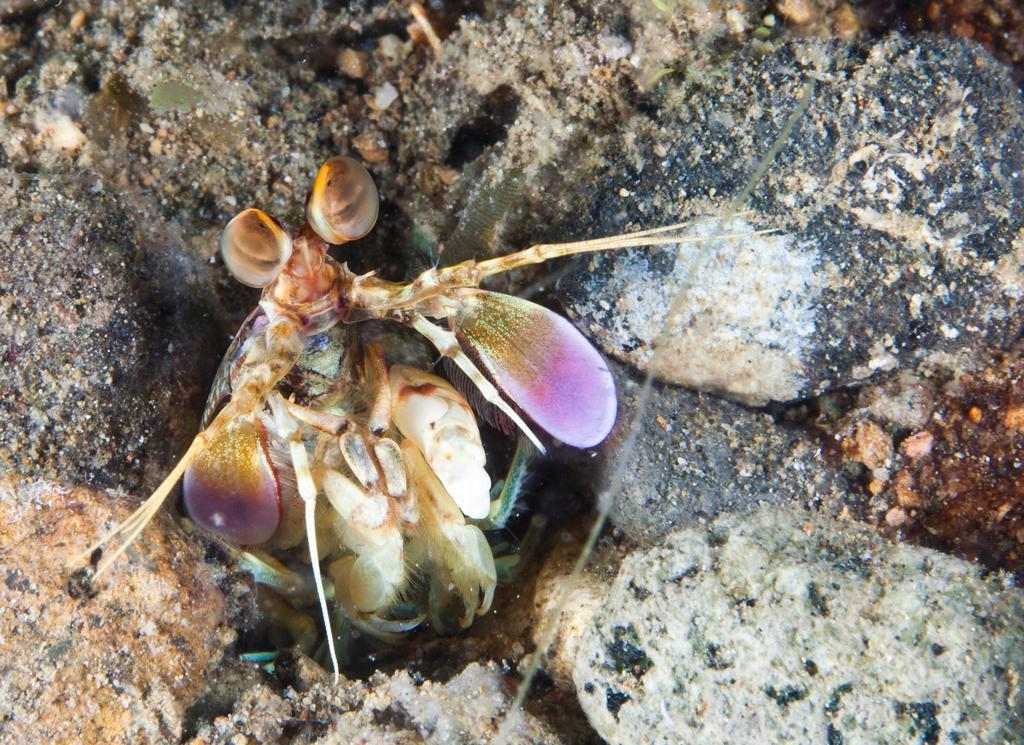How would you summarize this image in a sentence or two? In this image, in the middle, we can see an insect. In the background, we can see few rocks. 